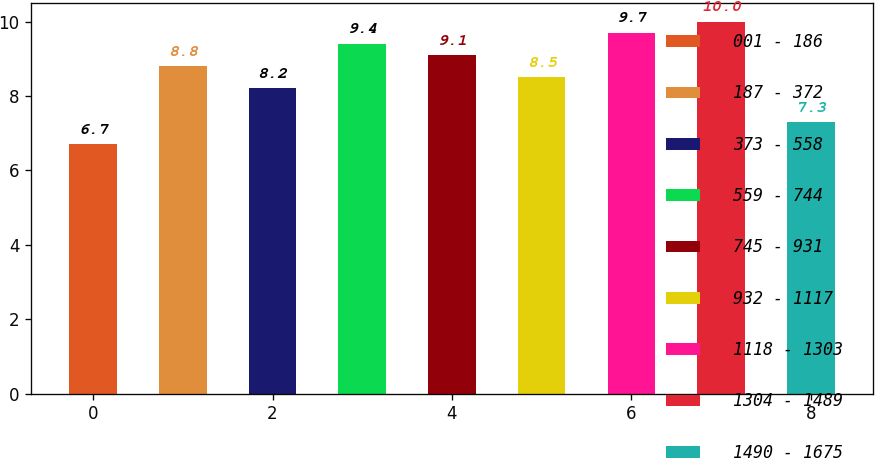<chart> <loc_0><loc_0><loc_500><loc_500><bar_chart><fcel>001 - 186<fcel>187 - 372<fcel>373 - 558<fcel>559 - 744<fcel>745 - 931<fcel>932 - 1117<fcel>1118 - 1303<fcel>1304 - 1489<fcel>1490 - 1675<nl><fcel>6.7<fcel>8.8<fcel>8.2<fcel>9.4<fcel>9.1<fcel>8.5<fcel>9.7<fcel>10<fcel>7.3<nl></chart> 